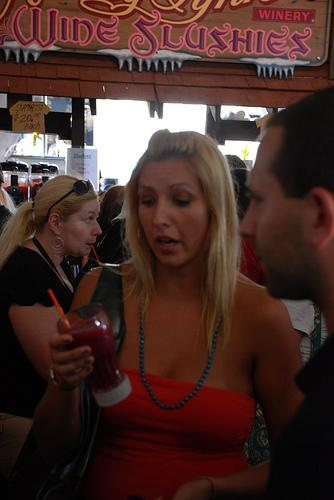Question: what color of necklace?
Choices:
A. Gold.
B. Blue.
C. Silver.
D. Black.
Answer with the letter. Answer: B Question: what type of top?
Choices:
A. Polo.
B. T-shirt.
C. Tube.
D. Sweater.
Answer with the letter. Answer: C Question: why is there a straw?
Choices:
A. For drinking.
B. Suck.
C. To use.
D. For blowing.
Answer with the letter. Answer: B Question: who has on red top?
Choices:
A. Lady.
B. Gentleman.
C. Child.
D. Woman.
Answer with the letter. Answer: A Question: what is on the lady head?
Choices:
A. A hat.
B. A ribbon.
C. Shades.
D. Glasses.
Answer with the letter. Answer: C 